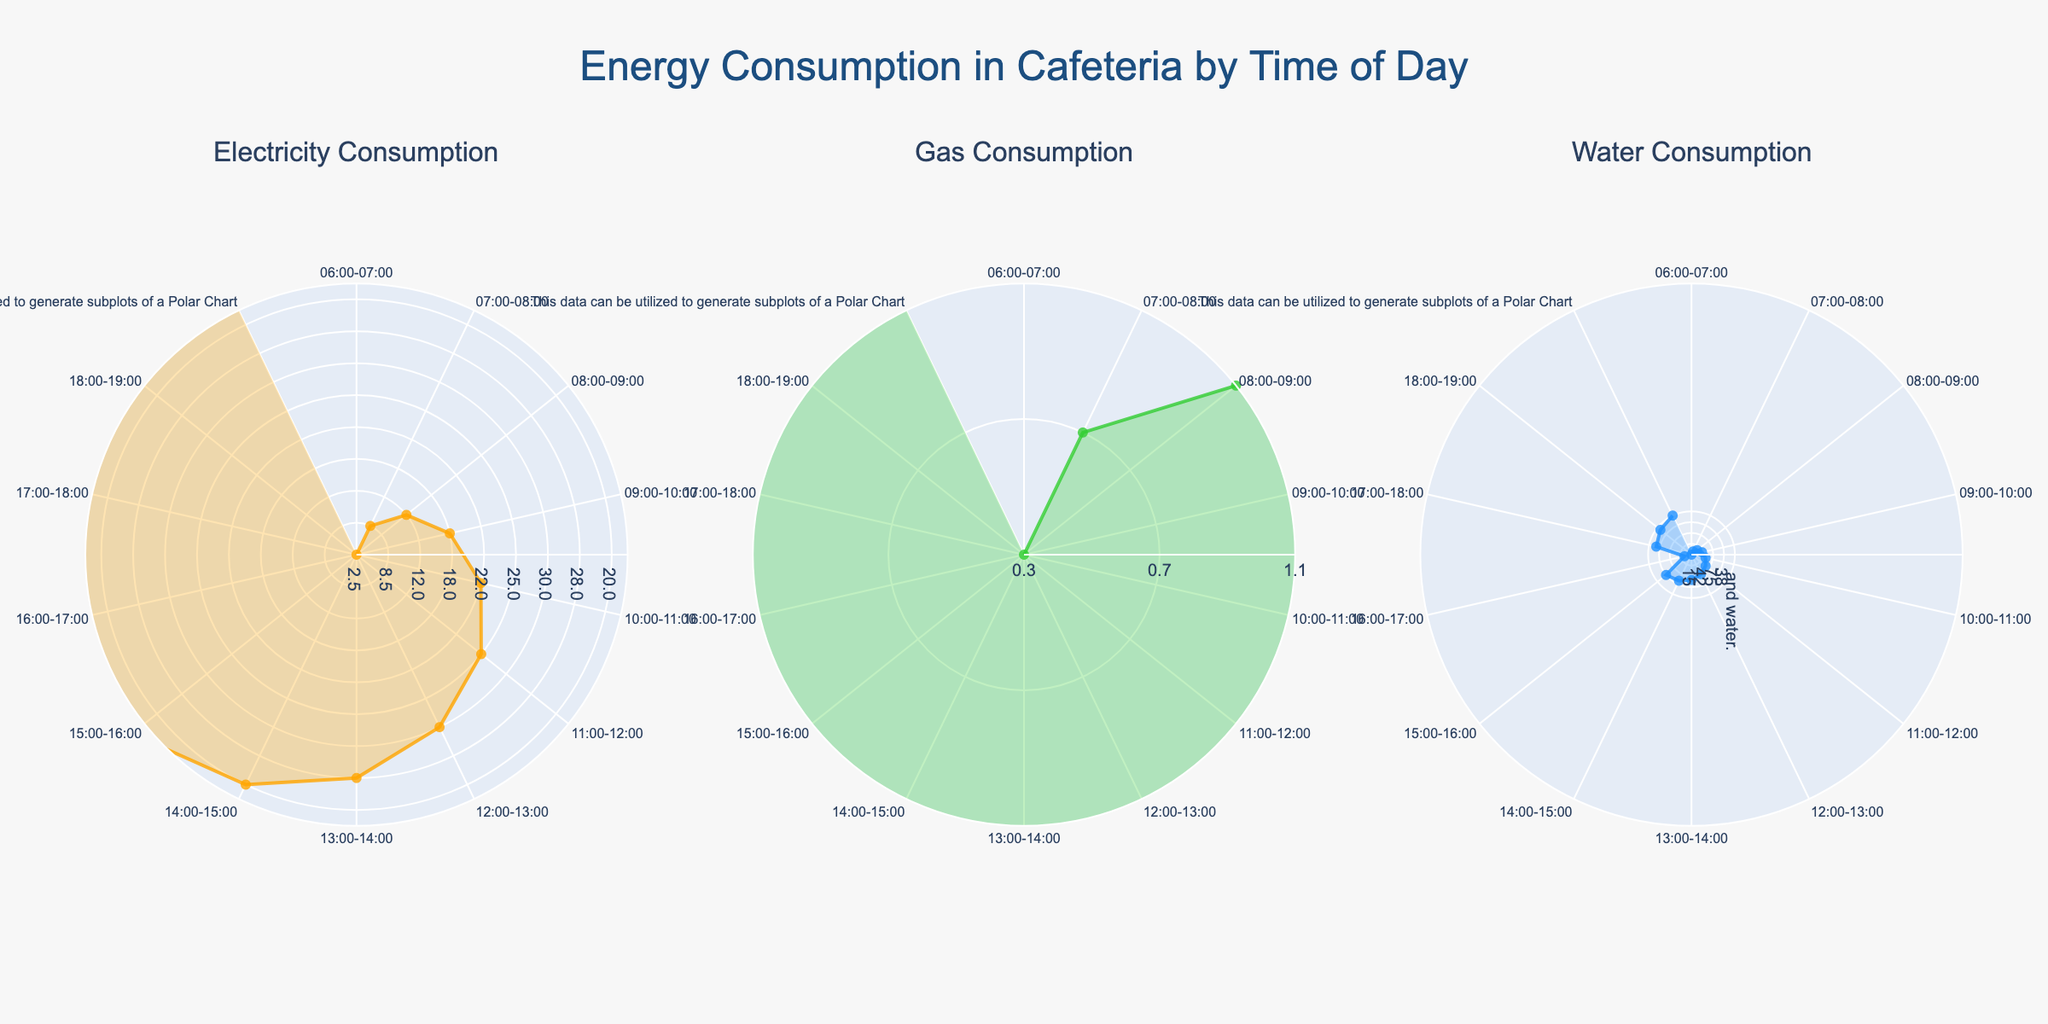What is the title of the figure? Look at the top of the figure where the title is typically displayed.
Answer: Energy Consumption in Cafeteria by Time of Day What colors are used for the plots of electricity, gas, and water? Observe the colors used in the Polar Charts for electricity, gas, and water subplots.
Answer: Orange, Green, Blue How does electricity consumption at 09:00-10:00 compare to gas consumption at the same time? Check the radial distances for both electricity and gas at 09:00-10:00 on their respective subplots.
Answer: Higher Which resource has the highest consumption overall and at what time? By comparing the peaks of the three polar plots, find the highest point in any subplot and note the corresponding time.
Answer: Electricity at 12:00-13:00 What's the total water consumption from 12:00-14:00? Add water consumption values from 12:00-13:00 and 13:00-14:00 (75 + 65).
Answer: 140 liters What is the largest difference between electricity and gas consumption at any given time? Subtract gas values from electricity values at each time point and find the maximum difference, which occurs at 12:00-13:00 (30 - 2).
Answer: 28 kWh Which hour shows the least consumption of water? Identify the hour with the smallest radial distance in the water subplot.
Answer: 06:00-07:00 What is the average electricity consumption between 06:00 and 09:00? Sum the electricity values from 06:00-07:00, 07:00-08:00, and 08:00-09:00, then divide by 3 ((2.5 + 8.5 + 12) / 3).
Answer: 7.67 kWh How does water consumption trend from 06:00-12:00 and from 12:00-18:00? Compare the radial distances in the water subplot from 06:00-12:00 and 12:00-18:00. Observe if they generally increase or decrease.
Answer: Increase, Decrease What time period shows the second highest gas consumption? Identify the second highest radial distance in the gas subplot and match it to the corresponding time label.
Answer: 12:00-13:00 